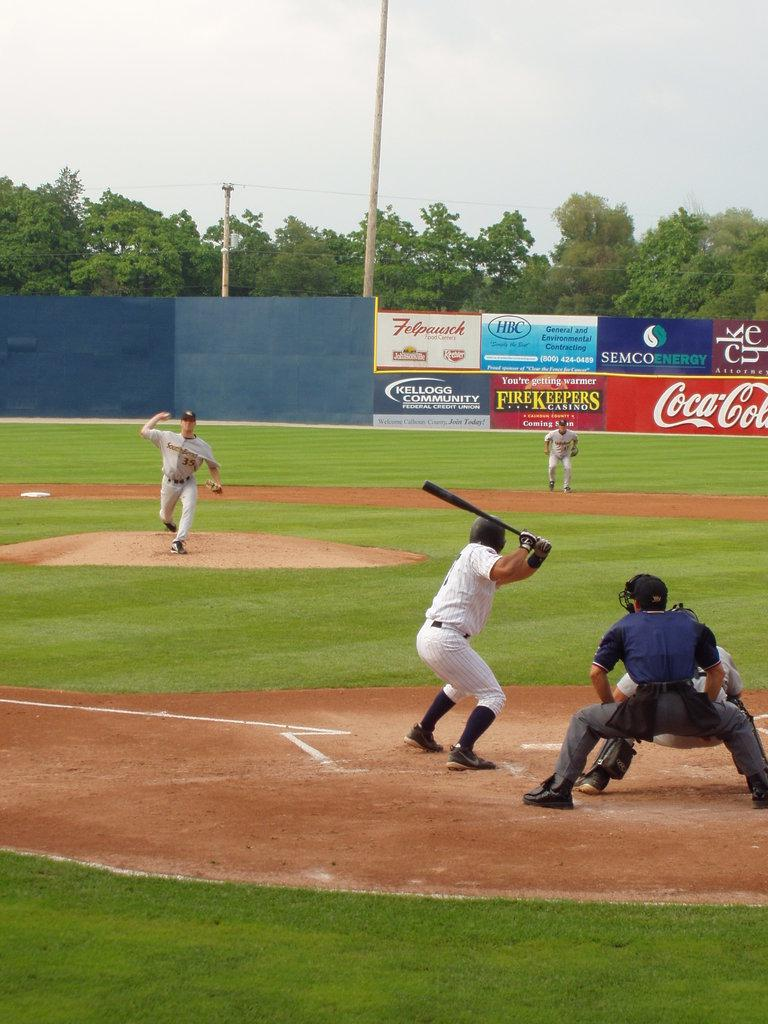<image>
Summarize the visual content of the image. A baseball game is being played in a stadium at has a banner up for Coca-Cola. 